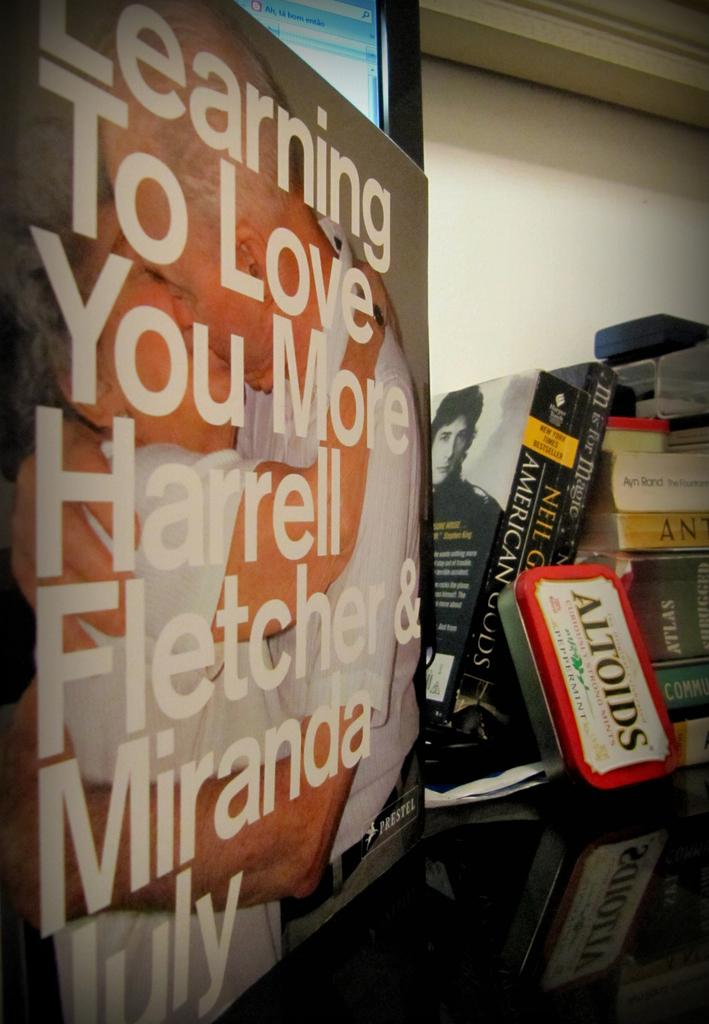<image>
Create a compact narrative representing the image presented. A can of red Altoids sits in front of a stack of books 